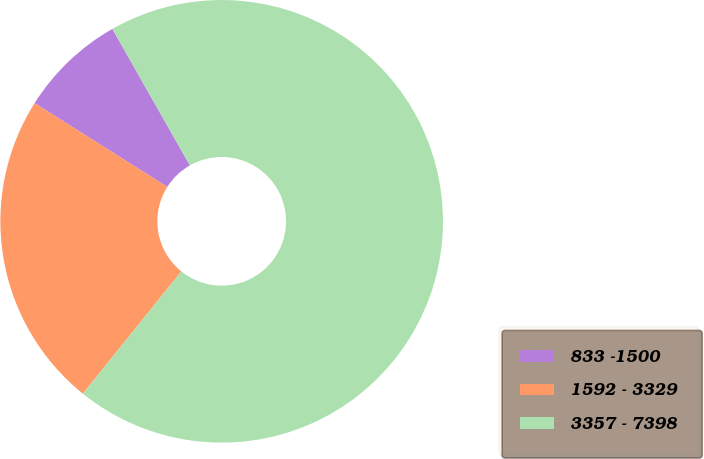Convert chart to OTSL. <chart><loc_0><loc_0><loc_500><loc_500><pie_chart><fcel>833 -1500<fcel>1592 - 3329<fcel>3357 - 7398<nl><fcel>7.81%<fcel>23.18%<fcel>69.02%<nl></chart> 